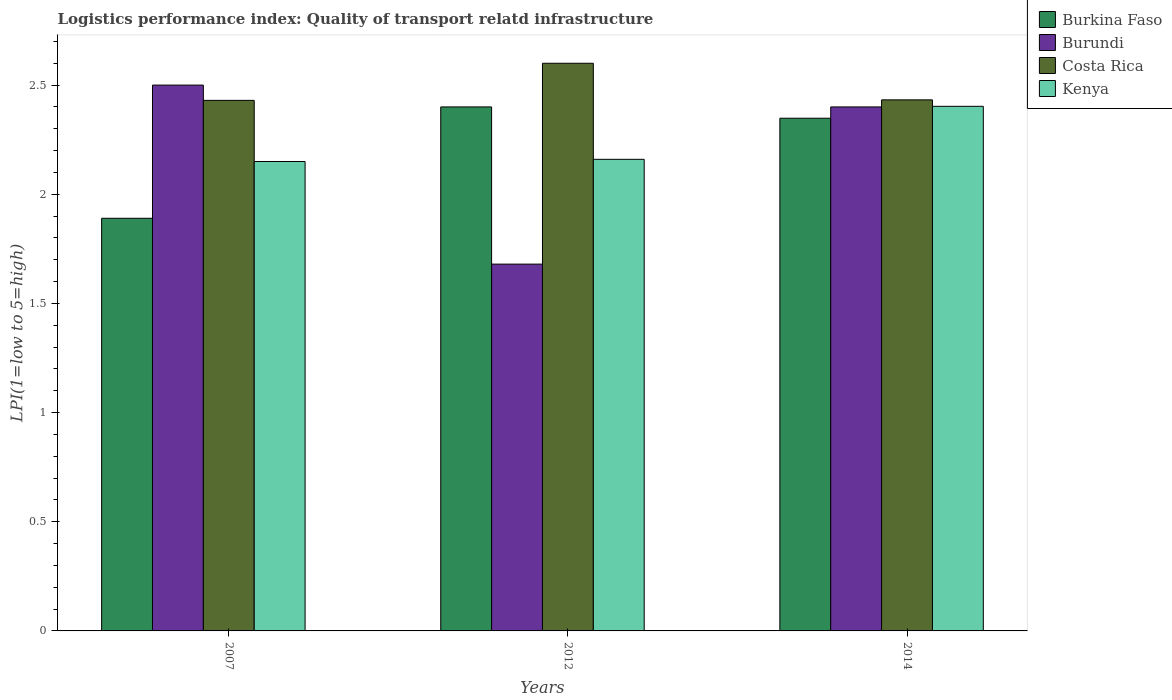How many groups of bars are there?
Ensure brevity in your answer.  3. Are the number of bars on each tick of the X-axis equal?
Offer a very short reply. Yes. How many bars are there on the 3rd tick from the left?
Give a very brief answer. 4. How many bars are there on the 2nd tick from the right?
Provide a succinct answer. 4. What is the logistics performance index in Costa Rica in 2014?
Ensure brevity in your answer.  2.43. Across all years, what is the minimum logistics performance index in Kenya?
Your answer should be very brief. 2.15. In which year was the logistics performance index in Kenya maximum?
Provide a short and direct response. 2014. In which year was the logistics performance index in Burkina Faso minimum?
Provide a succinct answer. 2007. What is the total logistics performance index in Burundi in the graph?
Your answer should be compact. 6.58. What is the difference between the logistics performance index in Costa Rica in 2012 and that in 2014?
Make the answer very short. 0.17. What is the difference between the logistics performance index in Costa Rica in 2007 and the logistics performance index in Burkina Faso in 2014?
Provide a succinct answer. 0.08. What is the average logistics performance index in Burkina Faso per year?
Keep it short and to the point. 2.21. In the year 2014, what is the difference between the logistics performance index in Kenya and logistics performance index in Burundi?
Offer a terse response. 0. What is the ratio of the logistics performance index in Kenya in 2007 to that in 2014?
Provide a succinct answer. 0.89. What is the difference between the highest and the second highest logistics performance index in Costa Rica?
Offer a terse response. 0.17. What is the difference between the highest and the lowest logistics performance index in Kenya?
Your answer should be compact. 0.25. Is the sum of the logistics performance index in Costa Rica in 2012 and 2014 greater than the maximum logistics performance index in Burkina Faso across all years?
Your answer should be very brief. Yes. Is it the case that in every year, the sum of the logistics performance index in Costa Rica and logistics performance index in Kenya is greater than the sum of logistics performance index in Burundi and logistics performance index in Burkina Faso?
Ensure brevity in your answer.  Yes. What does the 2nd bar from the left in 2014 represents?
Provide a short and direct response. Burundi. What does the 1st bar from the right in 2007 represents?
Your answer should be compact. Kenya. Is it the case that in every year, the sum of the logistics performance index in Burkina Faso and logistics performance index in Burundi is greater than the logistics performance index in Costa Rica?
Your answer should be compact. Yes. How many bars are there?
Offer a terse response. 12. How many years are there in the graph?
Provide a succinct answer. 3. What is the difference between two consecutive major ticks on the Y-axis?
Offer a very short reply. 0.5. Does the graph contain grids?
Give a very brief answer. No. What is the title of the graph?
Your answer should be compact. Logistics performance index: Quality of transport relatd infrastructure. Does "Guatemala" appear as one of the legend labels in the graph?
Make the answer very short. No. What is the label or title of the Y-axis?
Give a very brief answer. LPI(1=low to 5=high). What is the LPI(1=low to 5=high) in Burkina Faso in 2007?
Your answer should be very brief. 1.89. What is the LPI(1=low to 5=high) of Costa Rica in 2007?
Make the answer very short. 2.43. What is the LPI(1=low to 5=high) of Kenya in 2007?
Provide a succinct answer. 2.15. What is the LPI(1=low to 5=high) in Burundi in 2012?
Give a very brief answer. 1.68. What is the LPI(1=low to 5=high) of Kenya in 2012?
Provide a succinct answer. 2.16. What is the LPI(1=low to 5=high) in Burkina Faso in 2014?
Provide a short and direct response. 2.35. What is the LPI(1=low to 5=high) in Burundi in 2014?
Ensure brevity in your answer.  2.4. What is the LPI(1=low to 5=high) in Costa Rica in 2014?
Make the answer very short. 2.43. What is the LPI(1=low to 5=high) in Kenya in 2014?
Your response must be concise. 2.4. Across all years, what is the maximum LPI(1=low to 5=high) of Burkina Faso?
Ensure brevity in your answer.  2.4. Across all years, what is the maximum LPI(1=low to 5=high) of Burundi?
Make the answer very short. 2.5. Across all years, what is the maximum LPI(1=low to 5=high) of Kenya?
Keep it short and to the point. 2.4. Across all years, what is the minimum LPI(1=low to 5=high) in Burkina Faso?
Provide a succinct answer. 1.89. Across all years, what is the minimum LPI(1=low to 5=high) of Burundi?
Your answer should be very brief. 1.68. Across all years, what is the minimum LPI(1=low to 5=high) in Costa Rica?
Provide a short and direct response. 2.43. Across all years, what is the minimum LPI(1=low to 5=high) of Kenya?
Offer a very short reply. 2.15. What is the total LPI(1=low to 5=high) in Burkina Faso in the graph?
Give a very brief answer. 6.64. What is the total LPI(1=low to 5=high) in Burundi in the graph?
Offer a terse response. 6.58. What is the total LPI(1=low to 5=high) in Costa Rica in the graph?
Offer a terse response. 7.46. What is the total LPI(1=low to 5=high) of Kenya in the graph?
Your response must be concise. 6.71. What is the difference between the LPI(1=low to 5=high) in Burkina Faso in 2007 and that in 2012?
Give a very brief answer. -0.51. What is the difference between the LPI(1=low to 5=high) in Burundi in 2007 and that in 2012?
Your answer should be compact. 0.82. What is the difference between the LPI(1=low to 5=high) in Costa Rica in 2007 and that in 2012?
Ensure brevity in your answer.  -0.17. What is the difference between the LPI(1=low to 5=high) of Kenya in 2007 and that in 2012?
Ensure brevity in your answer.  -0.01. What is the difference between the LPI(1=low to 5=high) in Burkina Faso in 2007 and that in 2014?
Ensure brevity in your answer.  -0.46. What is the difference between the LPI(1=low to 5=high) in Costa Rica in 2007 and that in 2014?
Keep it short and to the point. -0. What is the difference between the LPI(1=low to 5=high) of Kenya in 2007 and that in 2014?
Offer a very short reply. -0.25. What is the difference between the LPI(1=low to 5=high) in Burkina Faso in 2012 and that in 2014?
Your answer should be very brief. 0.05. What is the difference between the LPI(1=low to 5=high) in Burundi in 2012 and that in 2014?
Your answer should be very brief. -0.72. What is the difference between the LPI(1=low to 5=high) in Costa Rica in 2012 and that in 2014?
Your answer should be very brief. 0.17. What is the difference between the LPI(1=low to 5=high) in Kenya in 2012 and that in 2014?
Ensure brevity in your answer.  -0.24. What is the difference between the LPI(1=low to 5=high) in Burkina Faso in 2007 and the LPI(1=low to 5=high) in Burundi in 2012?
Offer a very short reply. 0.21. What is the difference between the LPI(1=low to 5=high) in Burkina Faso in 2007 and the LPI(1=low to 5=high) in Costa Rica in 2012?
Offer a very short reply. -0.71. What is the difference between the LPI(1=low to 5=high) in Burkina Faso in 2007 and the LPI(1=low to 5=high) in Kenya in 2012?
Your answer should be compact. -0.27. What is the difference between the LPI(1=low to 5=high) in Burundi in 2007 and the LPI(1=low to 5=high) in Costa Rica in 2012?
Your response must be concise. -0.1. What is the difference between the LPI(1=low to 5=high) in Burundi in 2007 and the LPI(1=low to 5=high) in Kenya in 2012?
Your answer should be very brief. 0.34. What is the difference between the LPI(1=low to 5=high) in Costa Rica in 2007 and the LPI(1=low to 5=high) in Kenya in 2012?
Ensure brevity in your answer.  0.27. What is the difference between the LPI(1=low to 5=high) in Burkina Faso in 2007 and the LPI(1=low to 5=high) in Burundi in 2014?
Offer a terse response. -0.51. What is the difference between the LPI(1=low to 5=high) in Burkina Faso in 2007 and the LPI(1=low to 5=high) in Costa Rica in 2014?
Offer a very short reply. -0.54. What is the difference between the LPI(1=low to 5=high) in Burkina Faso in 2007 and the LPI(1=low to 5=high) in Kenya in 2014?
Offer a terse response. -0.51. What is the difference between the LPI(1=low to 5=high) in Burundi in 2007 and the LPI(1=low to 5=high) in Costa Rica in 2014?
Offer a very short reply. 0.07. What is the difference between the LPI(1=low to 5=high) of Burundi in 2007 and the LPI(1=low to 5=high) of Kenya in 2014?
Your answer should be very brief. 0.1. What is the difference between the LPI(1=low to 5=high) of Costa Rica in 2007 and the LPI(1=low to 5=high) of Kenya in 2014?
Keep it short and to the point. 0.03. What is the difference between the LPI(1=low to 5=high) of Burkina Faso in 2012 and the LPI(1=low to 5=high) of Burundi in 2014?
Keep it short and to the point. 0. What is the difference between the LPI(1=low to 5=high) in Burkina Faso in 2012 and the LPI(1=low to 5=high) in Costa Rica in 2014?
Make the answer very short. -0.03. What is the difference between the LPI(1=low to 5=high) of Burkina Faso in 2012 and the LPI(1=low to 5=high) of Kenya in 2014?
Offer a very short reply. -0. What is the difference between the LPI(1=low to 5=high) in Burundi in 2012 and the LPI(1=low to 5=high) in Costa Rica in 2014?
Your response must be concise. -0.75. What is the difference between the LPI(1=low to 5=high) of Burundi in 2012 and the LPI(1=low to 5=high) of Kenya in 2014?
Make the answer very short. -0.72. What is the difference between the LPI(1=low to 5=high) of Costa Rica in 2012 and the LPI(1=low to 5=high) of Kenya in 2014?
Offer a very short reply. 0.2. What is the average LPI(1=low to 5=high) of Burkina Faso per year?
Give a very brief answer. 2.21. What is the average LPI(1=low to 5=high) of Burundi per year?
Offer a very short reply. 2.19. What is the average LPI(1=low to 5=high) of Costa Rica per year?
Provide a succinct answer. 2.49. What is the average LPI(1=low to 5=high) in Kenya per year?
Offer a terse response. 2.24. In the year 2007, what is the difference between the LPI(1=low to 5=high) of Burkina Faso and LPI(1=low to 5=high) of Burundi?
Your answer should be compact. -0.61. In the year 2007, what is the difference between the LPI(1=low to 5=high) of Burkina Faso and LPI(1=low to 5=high) of Costa Rica?
Offer a terse response. -0.54. In the year 2007, what is the difference between the LPI(1=low to 5=high) of Burkina Faso and LPI(1=low to 5=high) of Kenya?
Your response must be concise. -0.26. In the year 2007, what is the difference between the LPI(1=low to 5=high) in Burundi and LPI(1=low to 5=high) in Costa Rica?
Offer a terse response. 0.07. In the year 2007, what is the difference between the LPI(1=low to 5=high) of Burundi and LPI(1=low to 5=high) of Kenya?
Your answer should be very brief. 0.35. In the year 2007, what is the difference between the LPI(1=low to 5=high) of Costa Rica and LPI(1=low to 5=high) of Kenya?
Give a very brief answer. 0.28. In the year 2012, what is the difference between the LPI(1=low to 5=high) of Burkina Faso and LPI(1=low to 5=high) of Burundi?
Make the answer very short. 0.72. In the year 2012, what is the difference between the LPI(1=low to 5=high) in Burkina Faso and LPI(1=low to 5=high) in Kenya?
Keep it short and to the point. 0.24. In the year 2012, what is the difference between the LPI(1=low to 5=high) in Burundi and LPI(1=low to 5=high) in Costa Rica?
Offer a terse response. -0.92. In the year 2012, what is the difference between the LPI(1=low to 5=high) of Burundi and LPI(1=low to 5=high) of Kenya?
Your response must be concise. -0.48. In the year 2012, what is the difference between the LPI(1=low to 5=high) in Costa Rica and LPI(1=low to 5=high) in Kenya?
Make the answer very short. 0.44. In the year 2014, what is the difference between the LPI(1=low to 5=high) in Burkina Faso and LPI(1=low to 5=high) in Burundi?
Provide a succinct answer. -0.05. In the year 2014, what is the difference between the LPI(1=low to 5=high) of Burkina Faso and LPI(1=low to 5=high) of Costa Rica?
Your response must be concise. -0.08. In the year 2014, what is the difference between the LPI(1=low to 5=high) in Burkina Faso and LPI(1=low to 5=high) in Kenya?
Your answer should be compact. -0.05. In the year 2014, what is the difference between the LPI(1=low to 5=high) of Burundi and LPI(1=low to 5=high) of Costa Rica?
Your answer should be very brief. -0.03. In the year 2014, what is the difference between the LPI(1=low to 5=high) in Burundi and LPI(1=low to 5=high) in Kenya?
Make the answer very short. -0. In the year 2014, what is the difference between the LPI(1=low to 5=high) in Costa Rica and LPI(1=low to 5=high) in Kenya?
Provide a succinct answer. 0.03. What is the ratio of the LPI(1=low to 5=high) in Burkina Faso in 2007 to that in 2012?
Ensure brevity in your answer.  0.79. What is the ratio of the LPI(1=low to 5=high) in Burundi in 2007 to that in 2012?
Ensure brevity in your answer.  1.49. What is the ratio of the LPI(1=low to 5=high) in Costa Rica in 2007 to that in 2012?
Your answer should be compact. 0.93. What is the ratio of the LPI(1=low to 5=high) of Kenya in 2007 to that in 2012?
Offer a very short reply. 1. What is the ratio of the LPI(1=low to 5=high) of Burkina Faso in 2007 to that in 2014?
Keep it short and to the point. 0.8. What is the ratio of the LPI(1=low to 5=high) in Burundi in 2007 to that in 2014?
Keep it short and to the point. 1.04. What is the ratio of the LPI(1=low to 5=high) in Costa Rica in 2007 to that in 2014?
Give a very brief answer. 1. What is the ratio of the LPI(1=low to 5=high) in Kenya in 2007 to that in 2014?
Ensure brevity in your answer.  0.89. What is the ratio of the LPI(1=low to 5=high) of Burkina Faso in 2012 to that in 2014?
Your answer should be compact. 1.02. What is the ratio of the LPI(1=low to 5=high) in Costa Rica in 2012 to that in 2014?
Your answer should be very brief. 1.07. What is the ratio of the LPI(1=low to 5=high) in Kenya in 2012 to that in 2014?
Your answer should be very brief. 0.9. What is the difference between the highest and the second highest LPI(1=low to 5=high) of Burkina Faso?
Keep it short and to the point. 0.05. What is the difference between the highest and the second highest LPI(1=low to 5=high) in Burundi?
Give a very brief answer. 0.1. What is the difference between the highest and the second highest LPI(1=low to 5=high) of Costa Rica?
Provide a short and direct response. 0.17. What is the difference between the highest and the second highest LPI(1=low to 5=high) of Kenya?
Your response must be concise. 0.24. What is the difference between the highest and the lowest LPI(1=low to 5=high) in Burkina Faso?
Keep it short and to the point. 0.51. What is the difference between the highest and the lowest LPI(1=low to 5=high) of Burundi?
Give a very brief answer. 0.82. What is the difference between the highest and the lowest LPI(1=low to 5=high) in Costa Rica?
Give a very brief answer. 0.17. What is the difference between the highest and the lowest LPI(1=low to 5=high) in Kenya?
Offer a terse response. 0.25. 